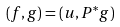Convert formula to latex. <formula><loc_0><loc_0><loc_500><loc_500>( f , g ) = ( u , P ^ { * } g )</formula> 